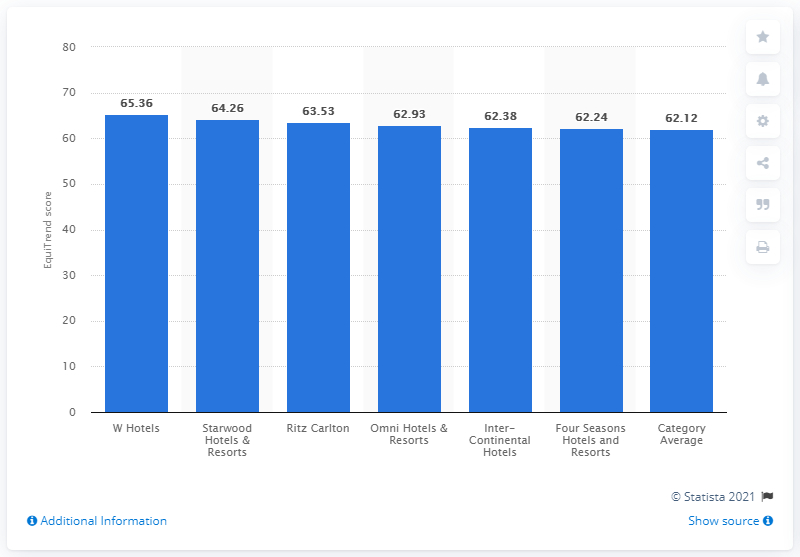Mention a couple of crucial points in this snapshot. In 2012, W Hotels' EquiTrend score was 65.36, indicating a high level of positive brand perception among consumers. 